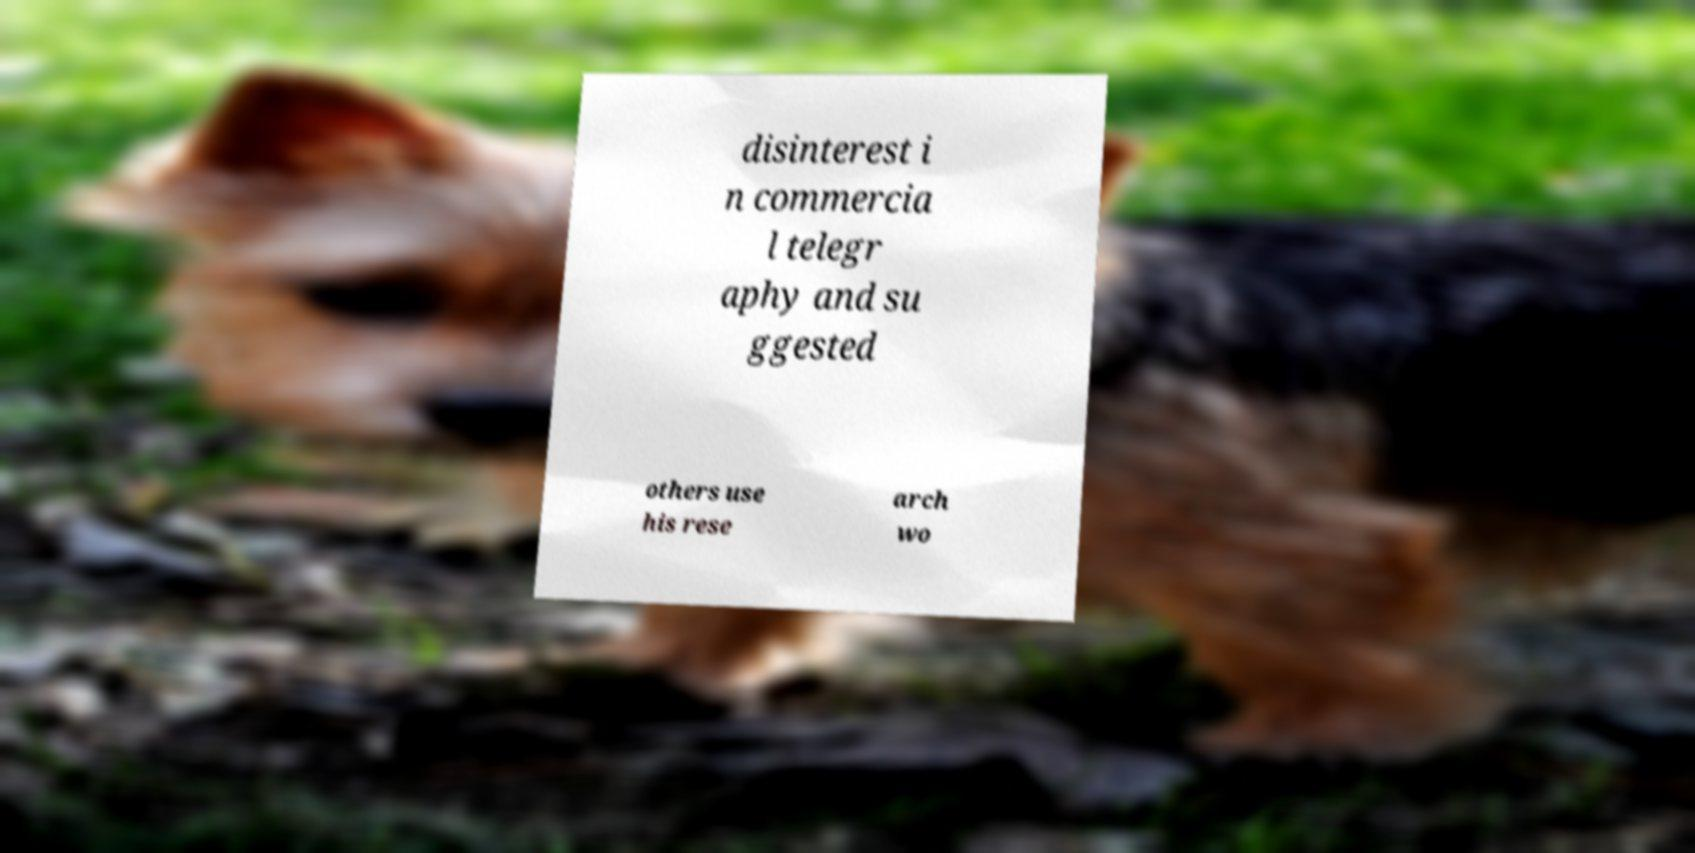For documentation purposes, I need the text within this image transcribed. Could you provide that? disinterest i n commercia l telegr aphy and su ggested others use his rese arch wo 